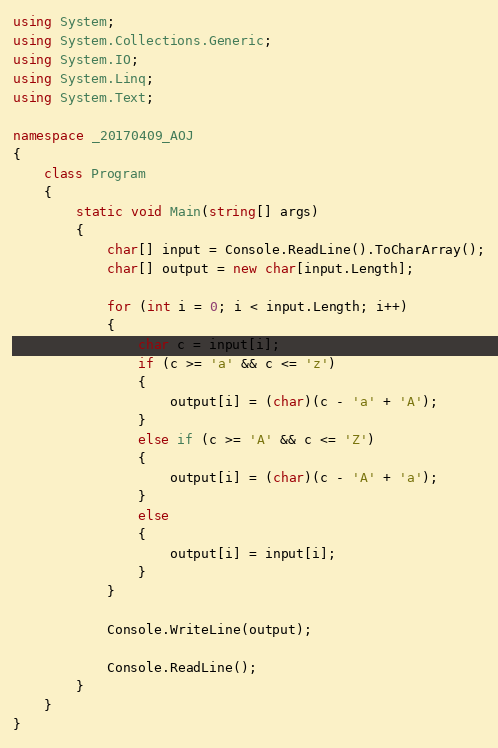<code> <loc_0><loc_0><loc_500><loc_500><_C#_>using System;
using System.Collections.Generic;
using System.IO;
using System.Linq;
using System.Text;

namespace _20170409_AOJ
{
    class Program
    {
        static void Main(string[] args)
        {
            char[] input = Console.ReadLine().ToCharArray();
            char[] output = new char[input.Length];

            for (int i = 0; i < input.Length; i++)
            {
                char c = input[i];
                if (c >= 'a' && c <= 'z')
                {
                    output[i] = (char)(c - 'a' + 'A');
                }
                else if (c >= 'A' && c <= 'Z')
                {
                    output[i] = (char)(c - 'A' + 'a');
                }
                else
                {
                    output[i] = input[i];
                }
            }

            Console.WriteLine(output);

            Console.ReadLine();
        }
    }
}</code> 